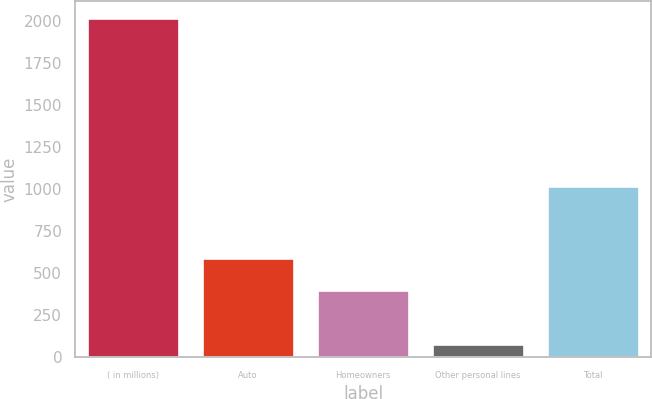<chart> <loc_0><loc_0><loc_500><loc_500><bar_chart><fcel>( in millions)<fcel>Auto<fcel>Homeowners<fcel>Other personal lines<fcel>Total<nl><fcel>2018<fcel>591.7<fcel>398<fcel>81<fcel>1016<nl></chart> 